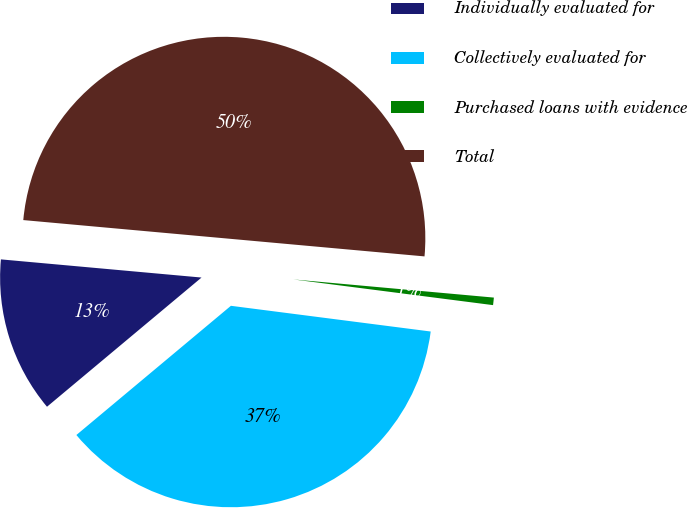Convert chart. <chart><loc_0><loc_0><loc_500><loc_500><pie_chart><fcel>Individually evaluated for<fcel>Collectively evaluated for<fcel>Purchased loans with evidence<fcel>Total<nl><fcel>12.52%<fcel>36.88%<fcel>0.6%<fcel>50.0%<nl></chart> 